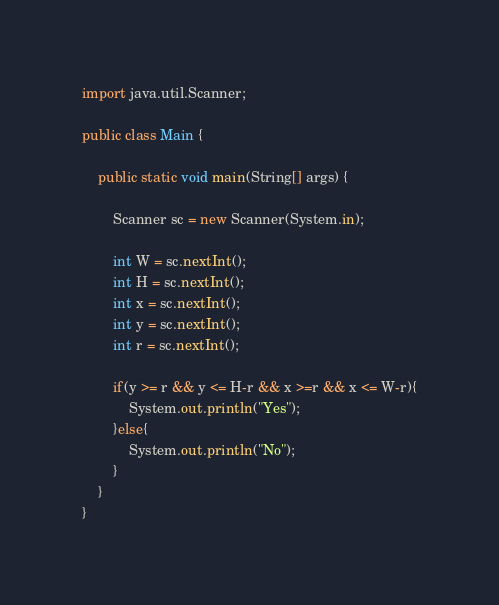Convert code to text. <code><loc_0><loc_0><loc_500><loc_500><_Java_>import java.util.Scanner;

public class Main {

	public static void main(String[] args) {

		Scanner sc = new Scanner(System.in);

		int W = sc.nextInt();
		int H = sc.nextInt();
		int x = sc.nextInt();
		int y = sc.nextInt();
		int r = sc.nextInt();

		if(y >= r && y <= H-r && x >=r && x <= W-r){
			System.out.println("Yes");
		}else{
			System.out.println("No");
		}
	}
}
</code> 